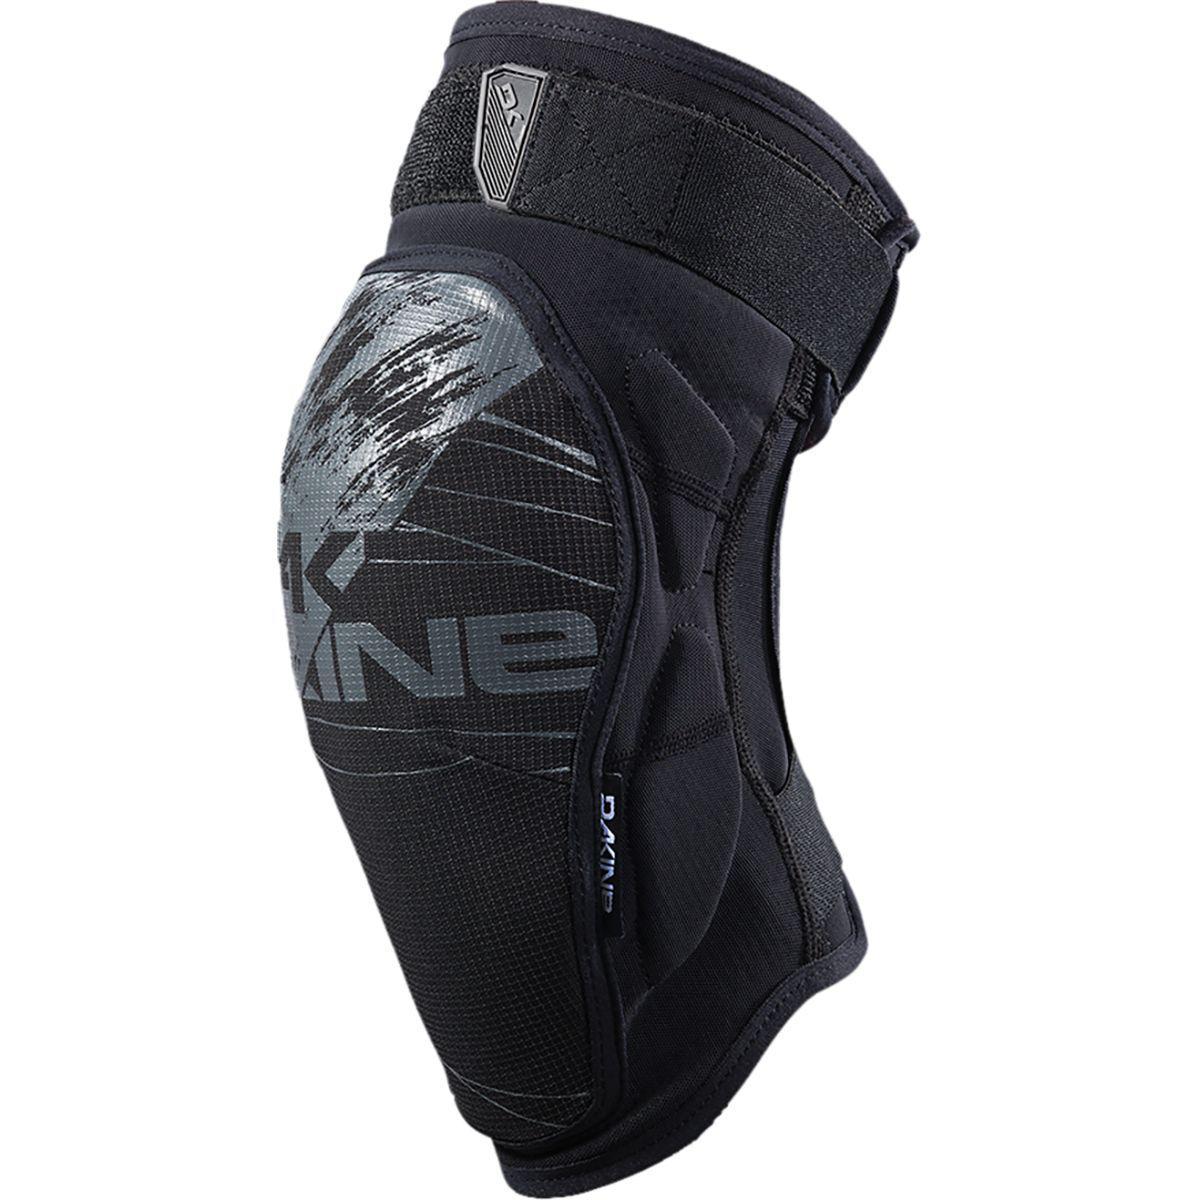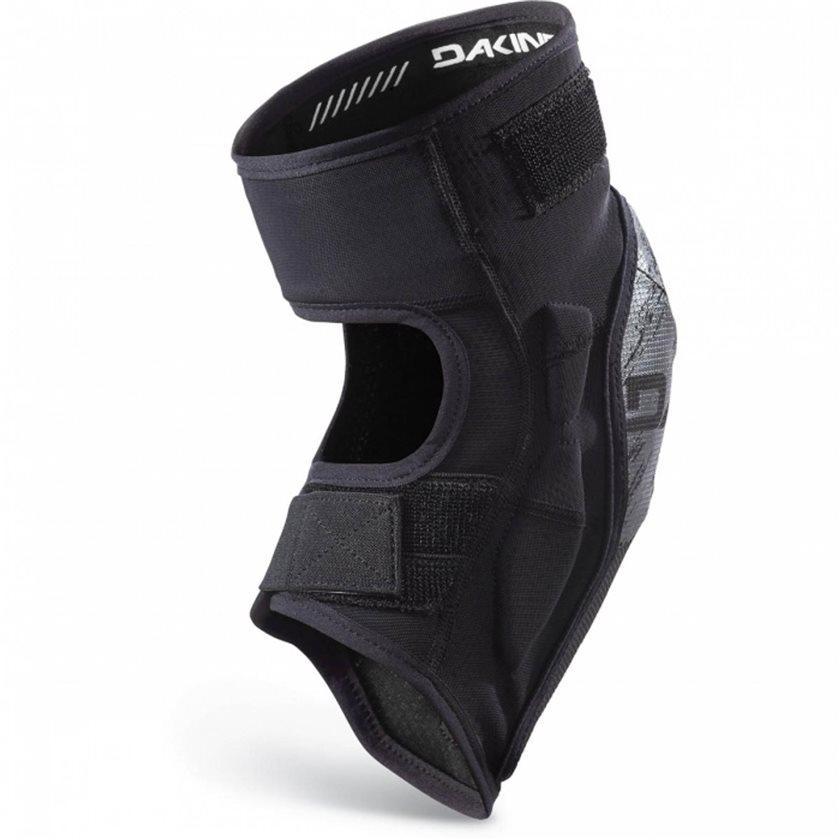The first image is the image on the left, the second image is the image on the right. Examine the images to the left and right. Is the description "Both pads are facing in the same direction." accurate? Answer yes or no. No. 